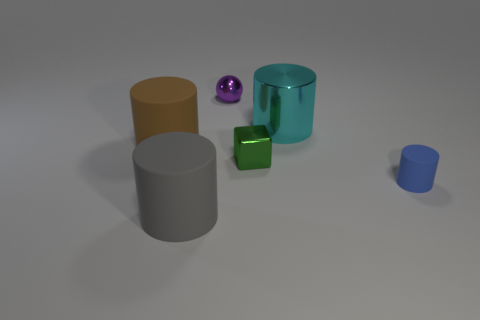How many cyan things are small rubber cubes or small cubes?
Offer a terse response. 0. Are there fewer big objects left of the big gray cylinder than small metallic balls that are in front of the purple object?
Your answer should be compact. No. Is there a gray metal cylinder that has the same size as the brown matte thing?
Keep it short and to the point. No. Does the matte cylinder on the right side of the cube have the same size as the ball?
Give a very brief answer. Yes. Are there more green metallic things than tiny yellow cylinders?
Make the answer very short. Yes. Is there a small cyan metal thing of the same shape as the purple object?
Give a very brief answer. No. The tiny metallic object in front of the big cyan metal thing has what shape?
Make the answer very short. Cube. There is a small shiny thing that is in front of the small thing that is behind the small cube; what number of big rubber objects are in front of it?
Keep it short and to the point. 1. Does the large object that is in front of the small blue cylinder have the same color as the metallic cylinder?
Your answer should be compact. No. What number of other objects are the same shape as the tiny green metallic thing?
Provide a succinct answer. 0. 